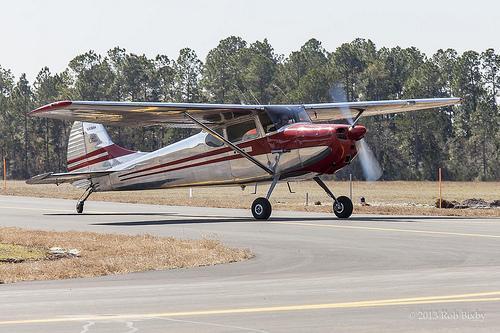How many planes are there?
Give a very brief answer. 1. 